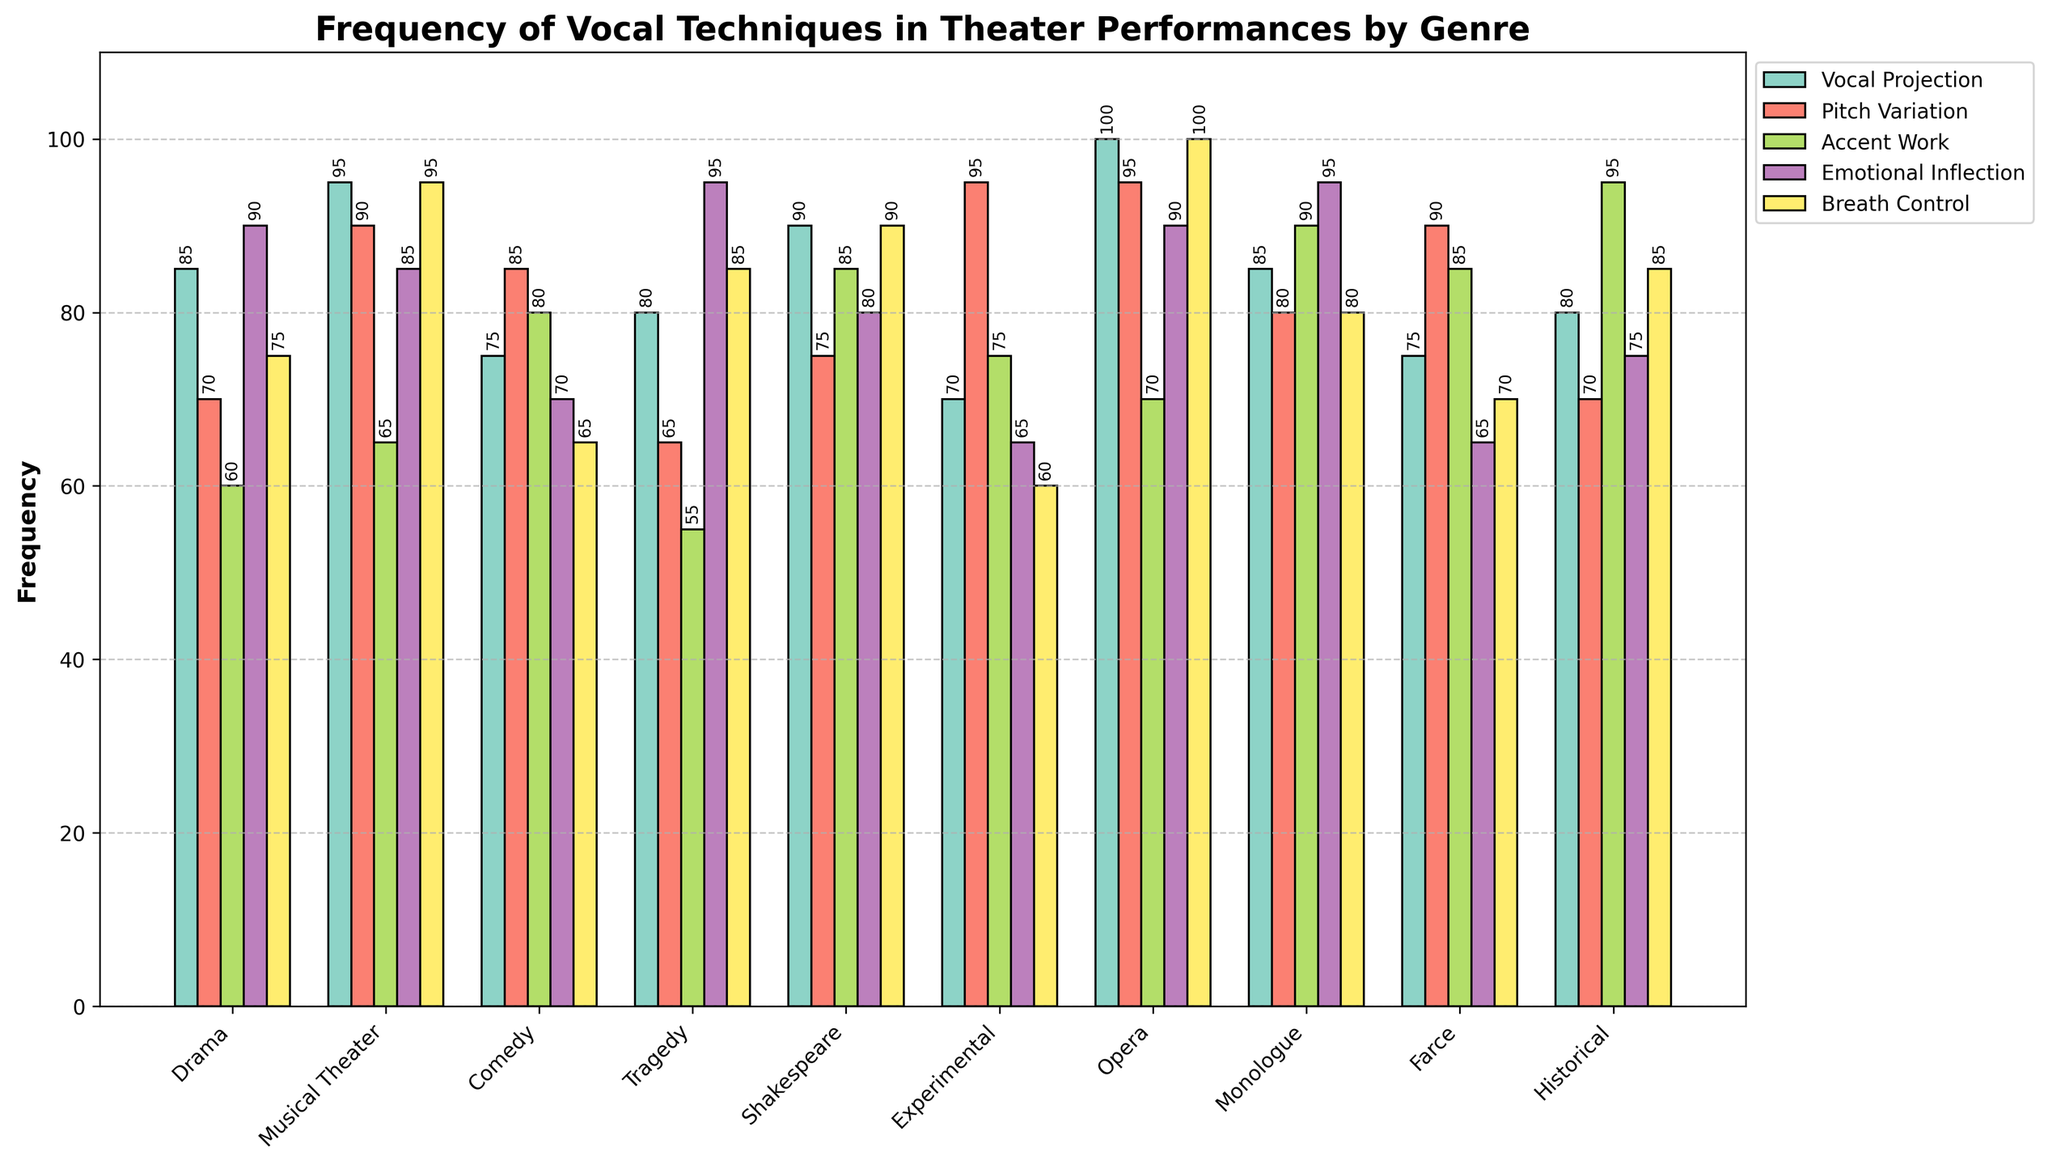What is the total frequency of Vocal Projection in Drama and Musical Theater combined? First, find the frequency of Vocal Projection in Drama (85) and in Musical Theater (95). Then, sum these two frequencies: 85 + 95 = 180.
Answer: 180 Which genre uses Emotional Inflection most frequently? Look for the genre with the highest bar for Emotional Inflection. Musical Theater and Monologue both have the highest frequency of 95.
Answer: Musical Theater, Monologue Is Accent Work more frequently used in Historical or Comedy performances? Compare the height of the Accent Work bars for Historical (95) and Comedy (80) genres. Historical is higher.
Answer: Historical What is the average frequency of Pitch Variation across all genres? Sum the Pitch Variation values: 70 + 90 + 85 + 65 + 75 + 95 + 95 + 80 + 90 + 70 = 815. Then, divide by the number of genres (10): 815 / 10 = 81.5.
Answer: 81.5 Which genre has the least frequency in Breath Control? Identify the shortest bar for Breath Control. Experimental has the lowest at 60.
Answer: Experimental How much more frequently is Breath Control used in Opera compared to Comedy? Find the values for Opera (100) and Comedy (65). Subtract Comedy's frequency from Opera's: 100 - 65 = 35.
Answer: 35 What is the sum of all Vocal Projection frequencies in Experimental and Farce genres? Add the Vocal Projection values for Experimental (70) and Farce (75): 70 + 75 = 145.
Answer: 145 In which vocal technique does Drama have the highest frequency? Look at Drama's frequencies for all techniques and find the highest: Emotional Inflection is 90.
Answer: Emotional Inflection Which genre shows a higher frequency in Pitch Variation, Experimental or Monologue? Compare the Pitch Variation values: Experimental (95) and Monologue (80). Experimental is higher.
Answer: Experimental How does the frequency of Accent Work in Shakespeare compare to Monologue? Compare the values for Accent Work in Shakespeare (85) and Monologue (90). Monologue has a higher frequency.
Answer: Monologue 